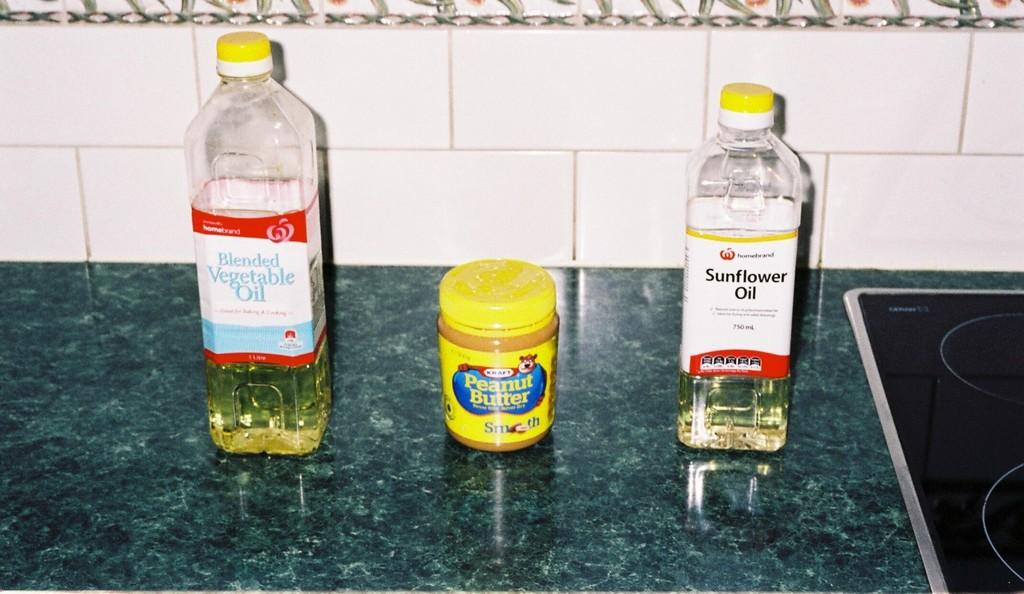<image>
Summarize the visual content of the image. Vegetable oil, peanut butter and sunflower oil sit on a kitchen counter. 